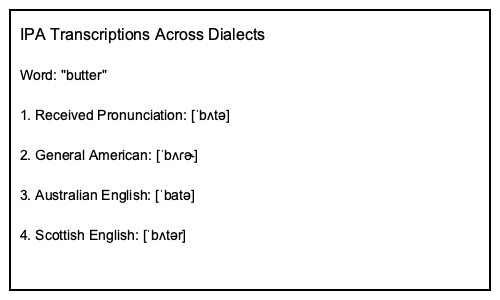Analyze the IPA transcriptions provided for the word "butter" across different English dialects. Which phonological process is evident in the General American pronunciation that distinguishes it from the others, and what does this reveal about the articulatory tendencies in this dialect? To answer this question, we need to examine the IPA transcriptions carefully and identify the unique features in the General American pronunciation:

1. Received Pronunciation: [ˈbʌtə]
2. General American: [ˈbʌɾɚ]
3. Australian English: [ˈbatə]
4. Scottish English: [ˈbʌtər]

The key difference in the General American pronunciation is the use of [ɾ] instead of [t]. This represents a phonological process known as flapping or tapping.

Step-by-step analysis:
1. The [t] in other dialects is replaced by [ɾ] in General American.
2. [ɾ] represents an alveolar tap or flap, which is a quick, single contact between the tongue tip and the alveolar ridge.
3. This process occurs in intervocalic positions (between vowels) in unstressed syllables.
4. Flapping is a form of lenition, where a "stronger" consonant (the stop [t]) becomes "weaker" (the flap [ɾ]).

This phonological process reveals that General American English has a tendency towards easier articulation in rapid speech. Flapping reduces the articulatory effort required to produce the [t] sound in this context, making the pronunciation more efficient.

Additionally, we can observe that the General American dialect uses the rhotacized schwa [ɚ] in the final syllable, indicating its rhotic nature, unlike the non-rhotic RP and Australian dialects.
Answer: Flapping; reveals a tendency towards articulatory efficiency in General American English. 